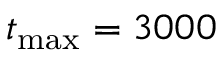Convert formula to latex. <formula><loc_0><loc_0><loc_500><loc_500>t _ { \max } = 3 0 0 0</formula> 